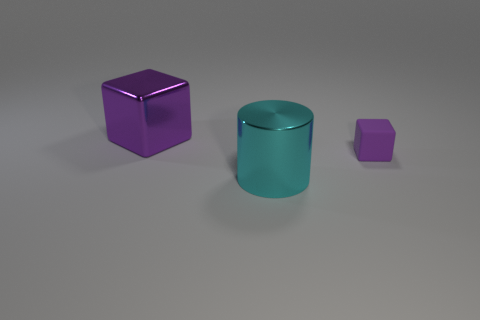What number of other cubes are the same color as the big block?
Your response must be concise. 1. There is a thing that is the same color as the small cube; what is it made of?
Provide a short and direct response. Metal. What number of other objects are there of the same color as the tiny cube?
Offer a terse response. 1. The object behind the purple thing right of the large purple block is what shape?
Your answer should be very brief. Cube. What number of big purple things are behind the big block?
Provide a succinct answer. 0. Is there a big green block made of the same material as the cyan cylinder?
Give a very brief answer. No. There is a purple cube that is the same size as the cyan cylinder; what is it made of?
Ensure brevity in your answer.  Metal. What size is the object that is on the left side of the rubber block and in front of the large purple metal thing?
Give a very brief answer. Large. There is a thing that is both right of the big metal block and behind the large metal cylinder; what color is it?
Give a very brief answer. Purple. Is the number of cyan metal objects right of the big cyan shiny cylinder less than the number of metal blocks to the right of the big shiny block?
Offer a terse response. No. 